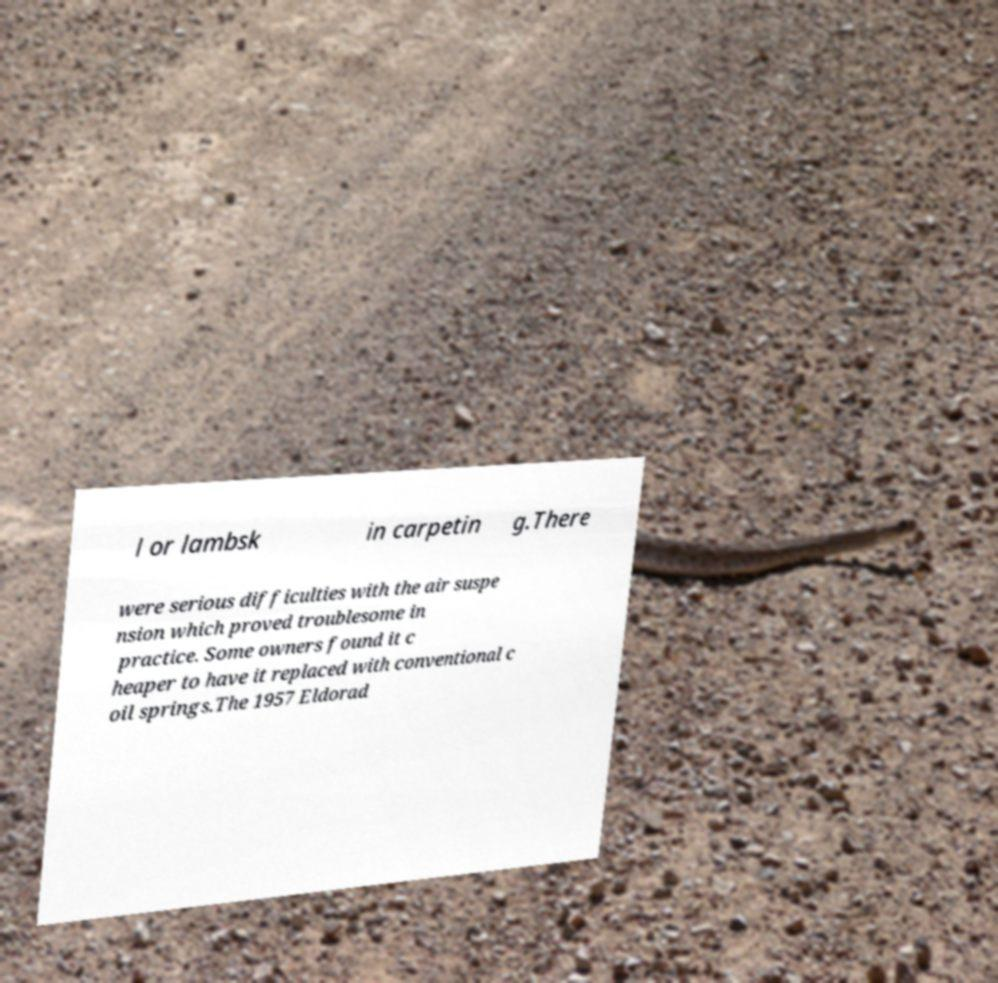What messages or text are displayed in this image? I need them in a readable, typed format. l or lambsk in carpetin g.There were serious difficulties with the air suspe nsion which proved troublesome in practice. Some owners found it c heaper to have it replaced with conventional c oil springs.The 1957 Eldorad 